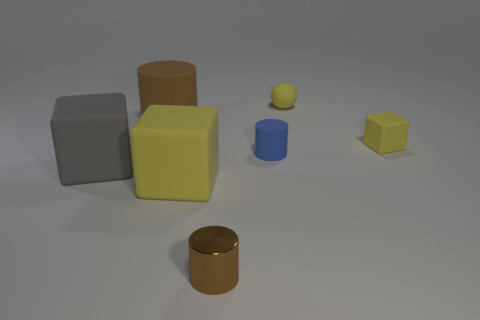How might the lighting affect the appearance of the objects? The lighting in the image creates soft shadows and subtle highlights, enhancing the three-dimensional appearance of the objects and emphasizing their shapes and textures. 